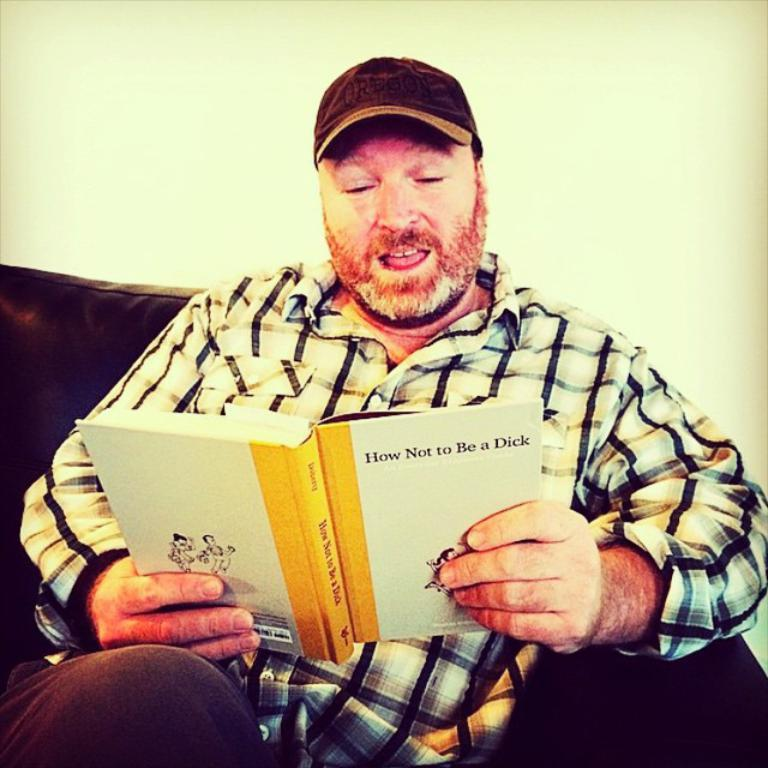What is the person in the image doing? The person is sitting in the sofa. What is the person holding in the image? The person is holding a book. What can be seen in the background of the image? There is a wall in the background of the image. What type of sweater is the person wearing in the image? There is no sweater visible in the image; the person is not wearing any clothing mentioned in the facts. 